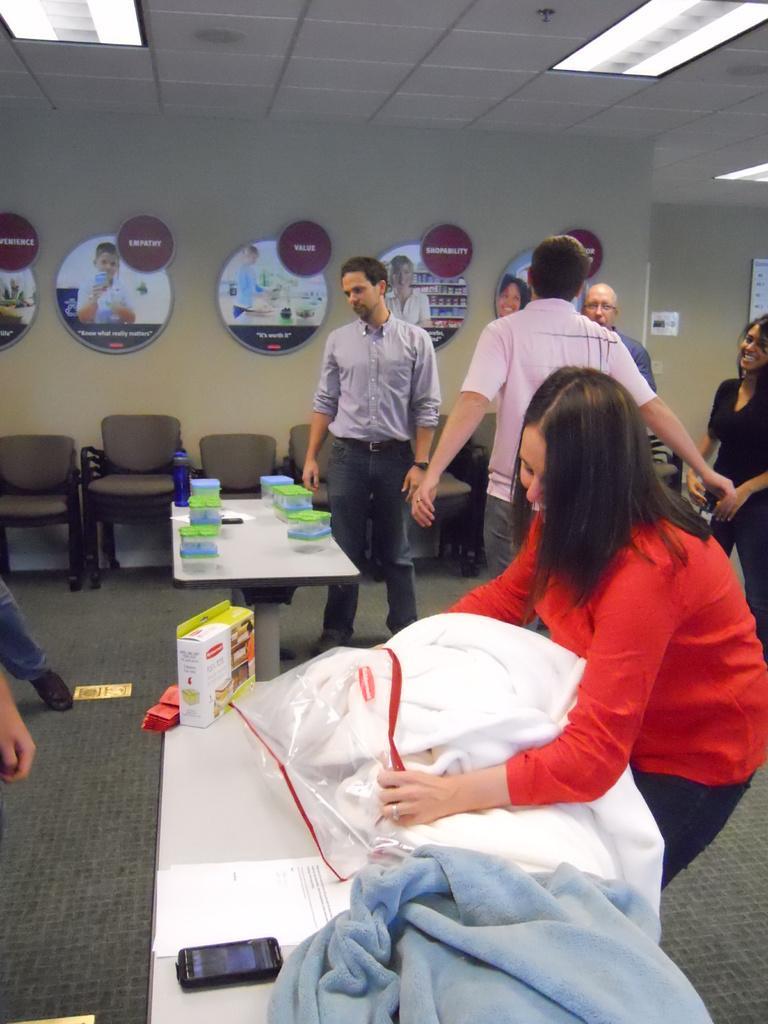Please provide a concise description of this image. Here we can see a group of people standing, and here is the table and boxes on it, and here are some objects, and here is the wall, and here is the light. 